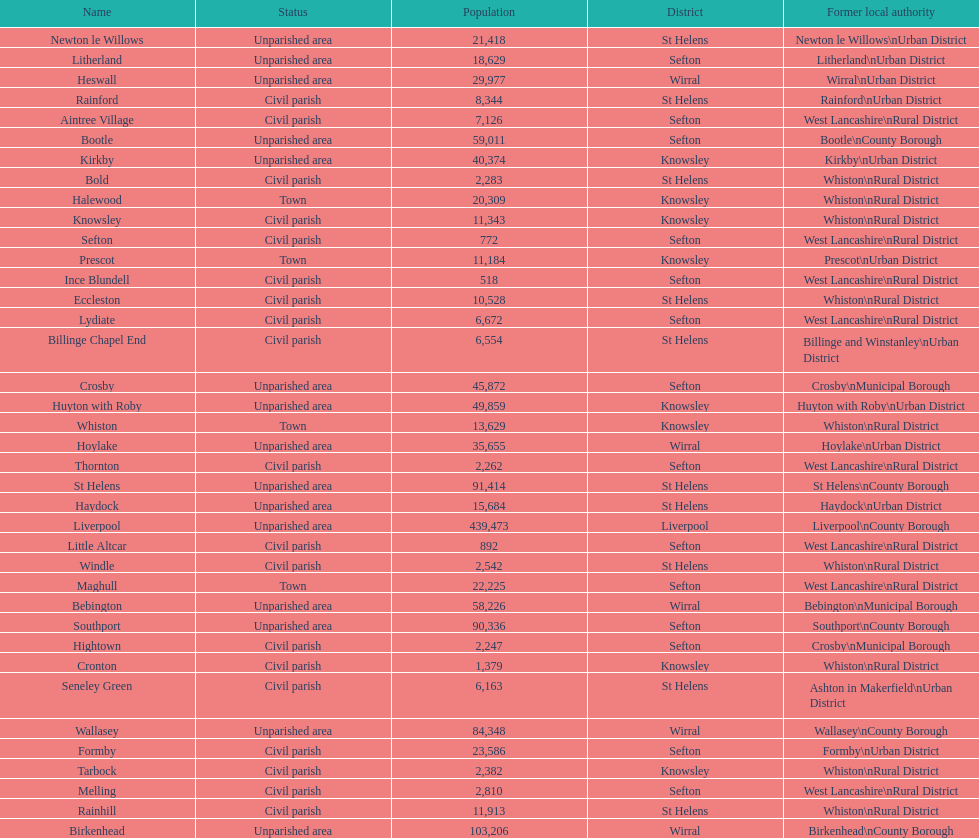Which area has the least number of residents? Ince Blundell. 